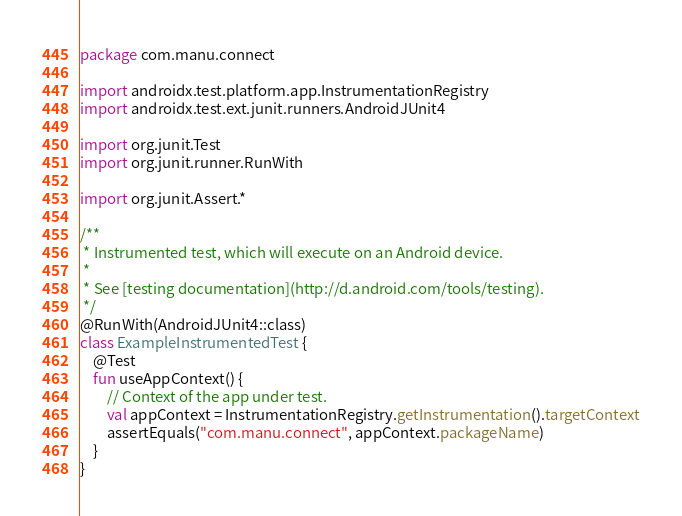<code> <loc_0><loc_0><loc_500><loc_500><_Kotlin_>package com.manu.connect

import androidx.test.platform.app.InstrumentationRegistry
import androidx.test.ext.junit.runners.AndroidJUnit4

import org.junit.Test
import org.junit.runner.RunWith

import org.junit.Assert.*

/**
 * Instrumented test, which will execute on an Android device.
 *
 * See [testing documentation](http://d.android.com/tools/testing).
 */
@RunWith(AndroidJUnit4::class)
class ExampleInstrumentedTest {
    @Test
    fun useAppContext() {
        // Context of the app under test.
        val appContext = InstrumentationRegistry.getInstrumentation().targetContext
        assertEquals("com.manu.connect", appContext.packageName)
    }
}</code> 